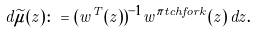<formula> <loc_0><loc_0><loc_500><loc_500>d \widetilde { \mu } ( z ) \colon = ( w ^ { T } ( z ) ) ^ { - 1 } w ^ { \pi t c h f o r k } ( z ) \, d z .</formula> 